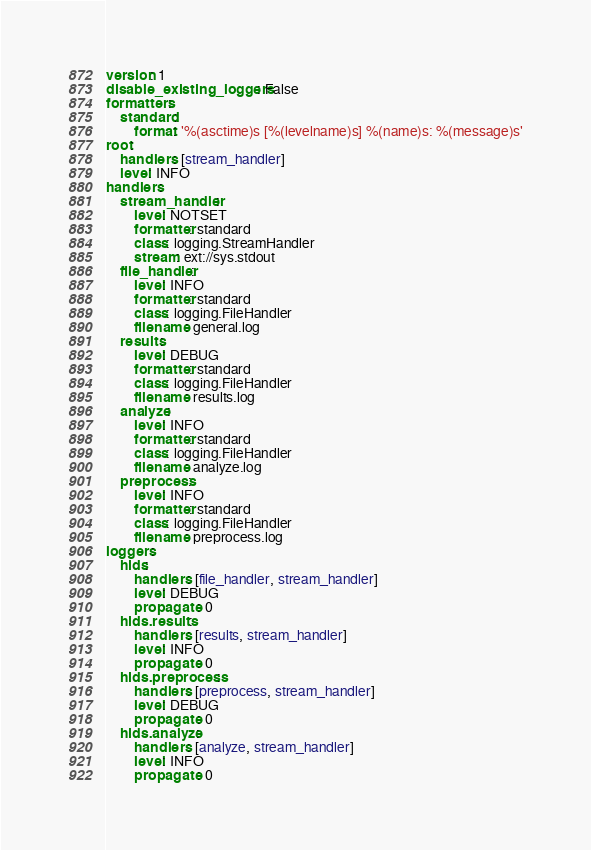Convert code to text. <code><loc_0><loc_0><loc_500><loc_500><_YAML_>version: 1
disable_existing_loggers: False
formatters:
    standard:
        format: '%(asctime)s [%(levelname)s] %(name)s: %(message)s'
root:
    handlers: [stream_handler]
    level: INFO
handlers:
    stream_handler:
        level: NOTSET
        formatter: standard
        class: logging.StreamHandler
        stream: ext://sys.stdout
    file_handler:
        level: INFO
        formatter: standard
        class: logging.FileHandler
        filename: general.log
    results:
        level: DEBUG
        formatter: standard
        class: logging.FileHandler
        filename: results.log
    analyze:
        level: INFO
        formatter: standard
        class: logging.FileHandler
        filename: analyze.log
    preprocess:
        level: INFO
        formatter: standard
        class: logging.FileHandler
        filename: preprocess.log
loggers:
    hids:
        handlers: [file_handler, stream_handler]
        level: DEBUG
        propagate: 0
    hids.results:
        handlers: [results, stream_handler]
        level: INFO
        propagate: 0
    hids.preprocess:
        handlers: [preprocess, stream_handler]
        level: DEBUG
        propagate: 0
    hids.analyze:
        handlers: [analyze, stream_handler]
        level: INFO
        propagate: 0
</code> 